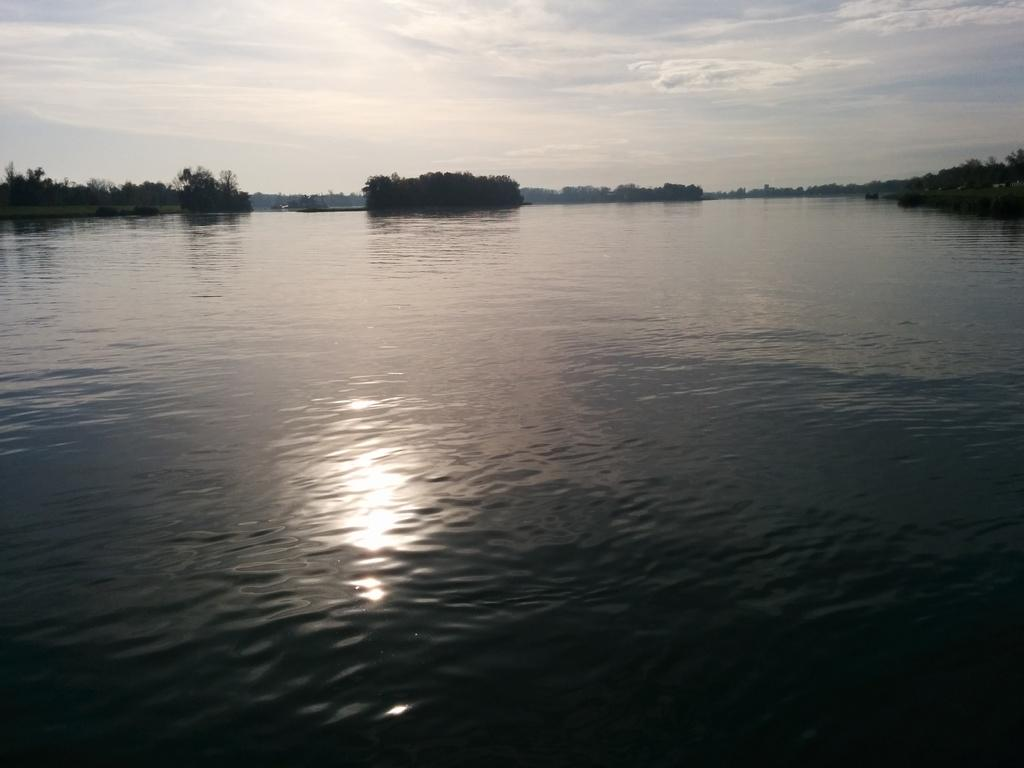What is the primary element visible in the image? There is water in the image. What type of vegetation can be seen in the image? There are trees in the image. What can be seen in the background of the image? The sky is visible in the background of the image. What type of cracker is floating on the water in the image? There is no cracker present in the image; it only features water and trees. 